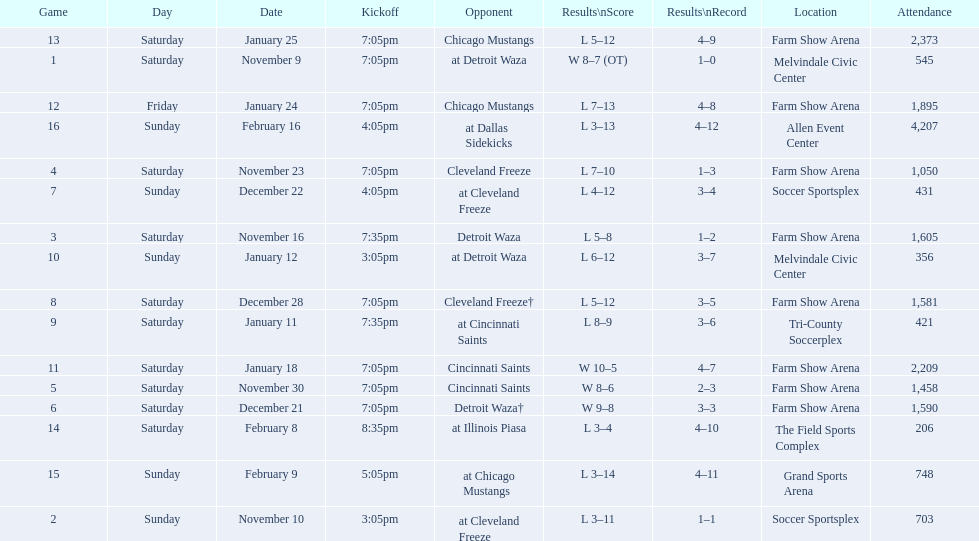Which opponent is listed after cleveland freeze in the table? Detroit Waza. 